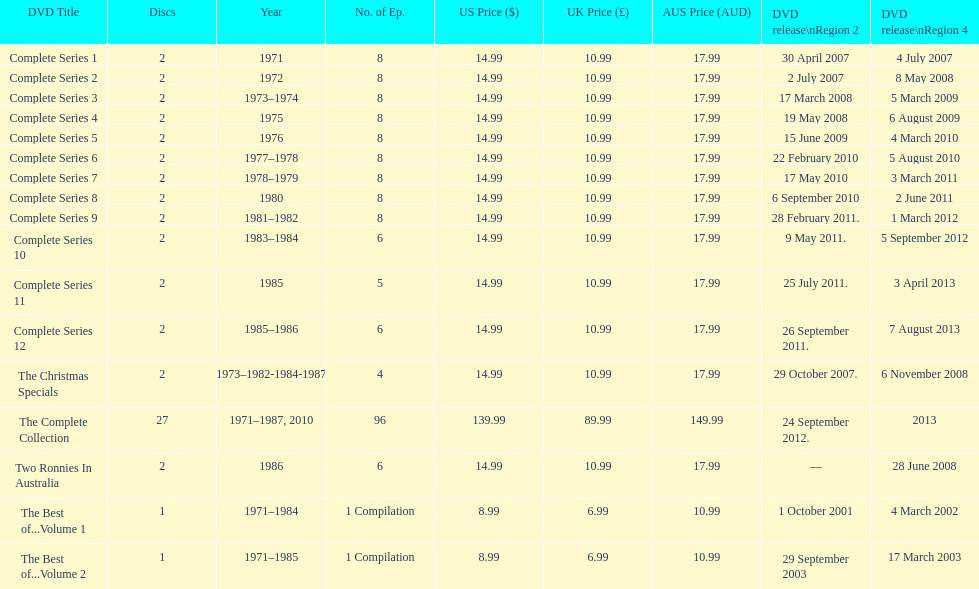What comes immediately after complete series 11? Complete Series 12. 